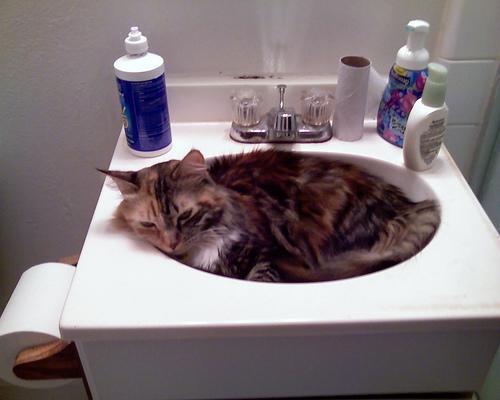How many sinks are there?
Give a very brief answer. 2. 